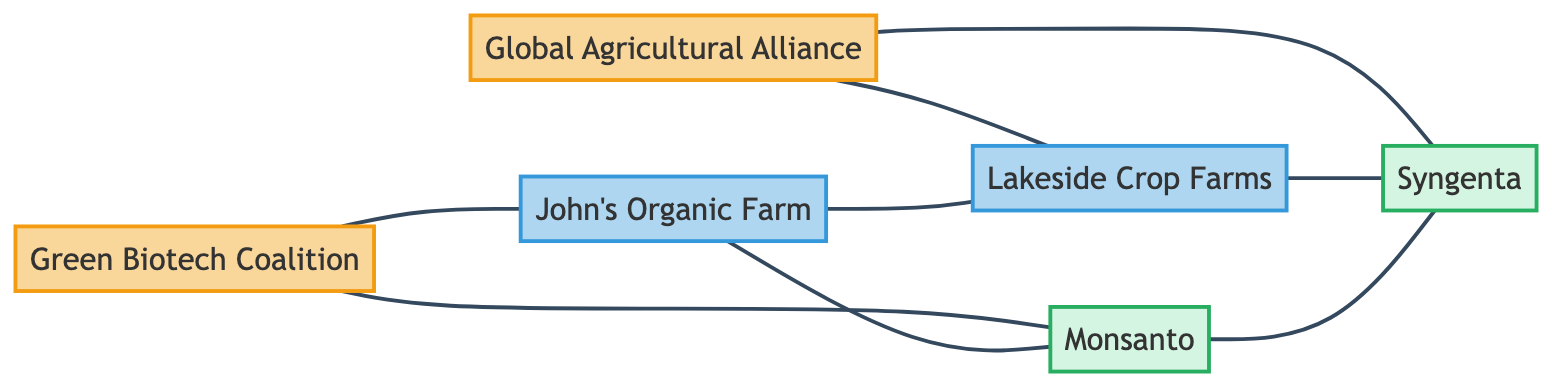What are the total number of nodes in the diagram? The diagram contains six nodes: two advocacy groups (Green Biotech Coalition and Global Agricultural Alliance), two farmers (John's Organic Farm and Lakeside Crop Farms), and two biotech firms (Monsanto and Syngenta).
Answer: 6 Which farmer is connected to the Green Biotech Coalition? In the diagram, the Green Biotech Coalition is directly connected to John's Organic Farm, indicating a relationship between this advocacy group and that farmer.
Answer: John's Organic Farm How many edges are there in the diagram? By counting the edges in the diagram, we find there are eight connections linking the nodes together: connections between advocacy groups, farmers, and biotech firms respectively.
Answer: 8 Which biotech firm is associated with Lakeside Crop Farms? The diagram shows that Lakeside Crop Farms is directly connected to Syngenta, indicating that this farm advocates or collaborates with this specific biotech firm.
Answer: Syngenta Is there a direct connection between the two biotech firms? Yes, the diagram shows a direct connection (an edge) between Monsanto and Syngenta, indicating some form of relationship or interaction between these firms.
Answer: Yes Which advocacy group has connections with both farmers? The connections reveal that the Green Biotech Coalition is linked to John's Organic Farm, while the Global Agricultural Alliance is connected to Lakeside Crop Farms; therefore, neither advocacy group has direct connections with both farmers. However, the farmers themselves are directly connected, showing that there's a collaboration or association between them despite not being connected to the same advocacy group.
Answer: None What is the relationship between Farmer1 and Farmer2? The diagram illustrates a direct connection between John's Organic Farm (Farmer1) and Lakeside Crop Farms (Farmer2), indicating a relationship between the two farmers, likely suggesting cooperation or shared interests in their practices.
Answer: Direct connection Which advocacy group is connected to the most nodes? By evaluating the connections, we note that the Green Biotech Coalition connects to two nodes (Monsanto and John's Organic Farm), and likewise, the Global Agricultural Alliance connects to two nodes (Syngenta and Lakeside Crop Farms), thus both advocacy groups are tied to an equal number of nodes, but neither has a broader network than the other.
Answer: Both equal 